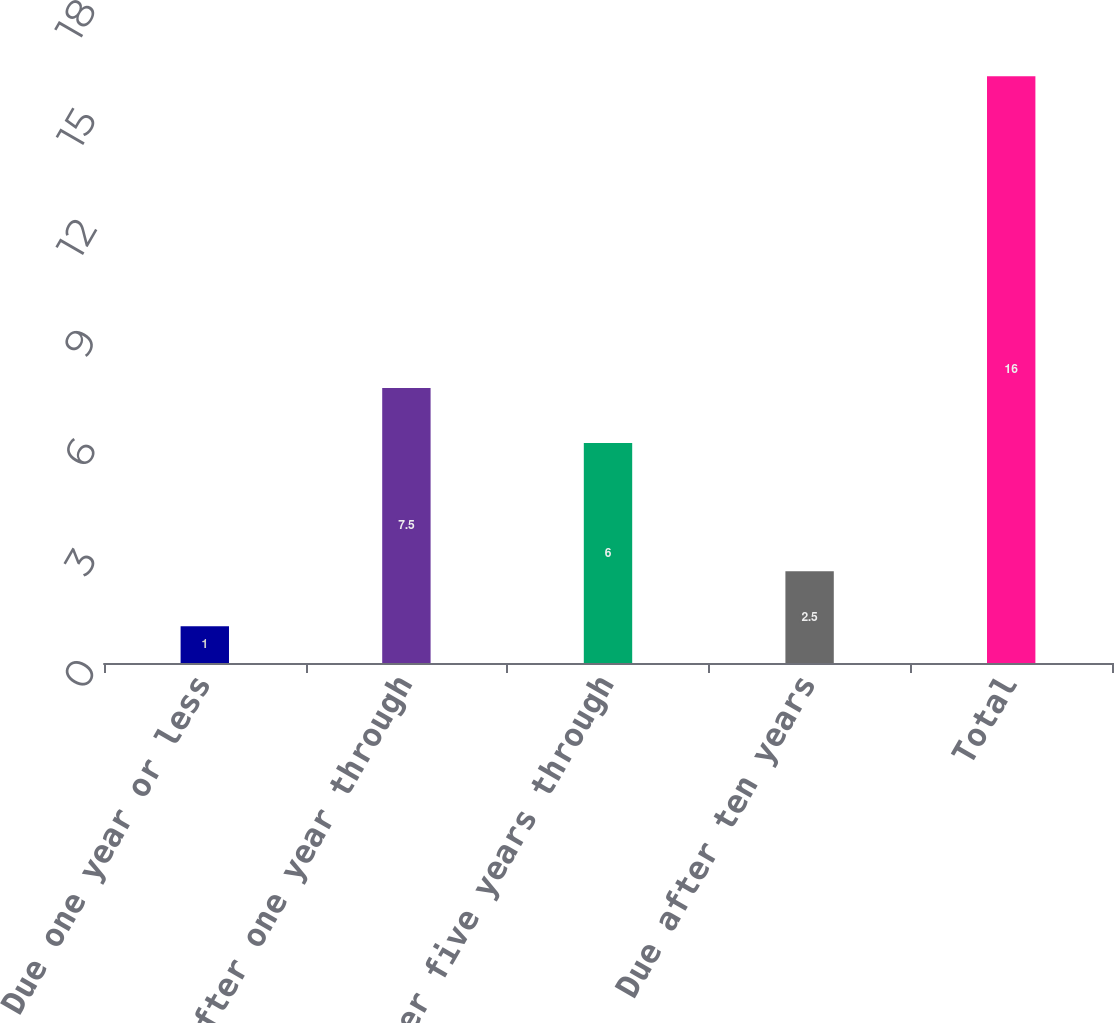Convert chart. <chart><loc_0><loc_0><loc_500><loc_500><bar_chart><fcel>Due one year or less<fcel>Due after one year through<fcel>Due after five years through<fcel>Due after ten years<fcel>Total<nl><fcel>1<fcel>7.5<fcel>6<fcel>2.5<fcel>16<nl></chart> 